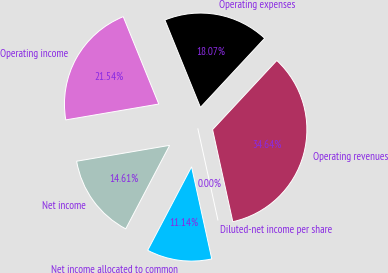<chart> <loc_0><loc_0><loc_500><loc_500><pie_chart><fcel>Operating revenues<fcel>Operating expenses<fcel>Operating income<fcel>Net income<fcel>Net income allocated to common<fcel>Diluted-net income per share<nl><fcel>34.64%<fcel>18.07%<fcel>21.54%<fcel>14.61%<fcel>11.14%<fcel>0.0%<nl></chart> 